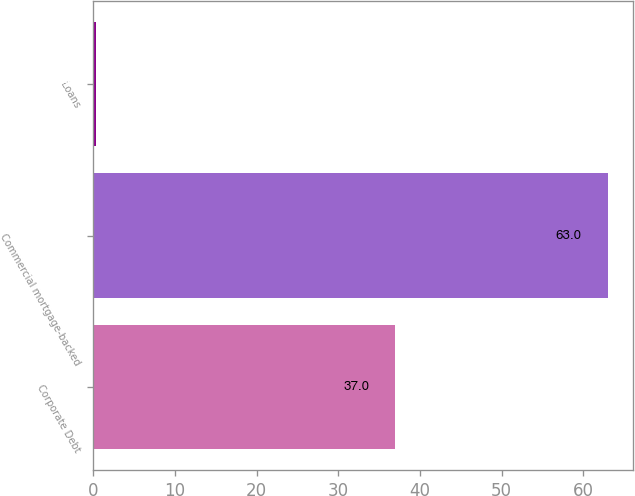Convert chart. <chart><loc_0><loc_0><loc_500><loc_500><bar_chart><fcel>Corporate Debt<fcel>Commercial mortgage-backed<fcel>Loans<nl><fcel>37<fcel>63<fcel>0.29<nl></chart> 